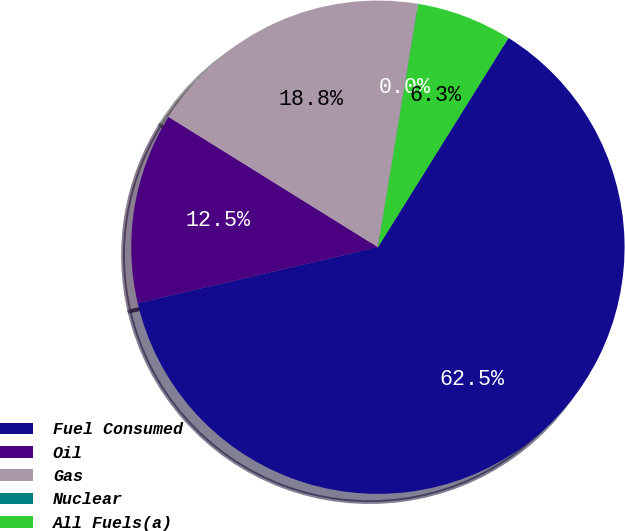Convert chart. <chart><loc_0><loc_0><loc_500><loc_500><pie_chart><fcel>Fuel Consumed<fcel>Oil<fcel>Gas<fcel>Nuclear<fcel>All Fuels(a)<nl><fcel>62.48%<fcel>12.5%<fcel>18.75%<fcel>0.01%<fcel>6.26%<nl></chart> 